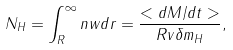Convert formula to latex. <formula><loc_0><loc_0><loc_500><loc_500>N _ { H } = \int _ { R } ^ { \infty } n w d r = \frac { < d M / d t > } { R v \delta m _ { H } } ,</formula> 